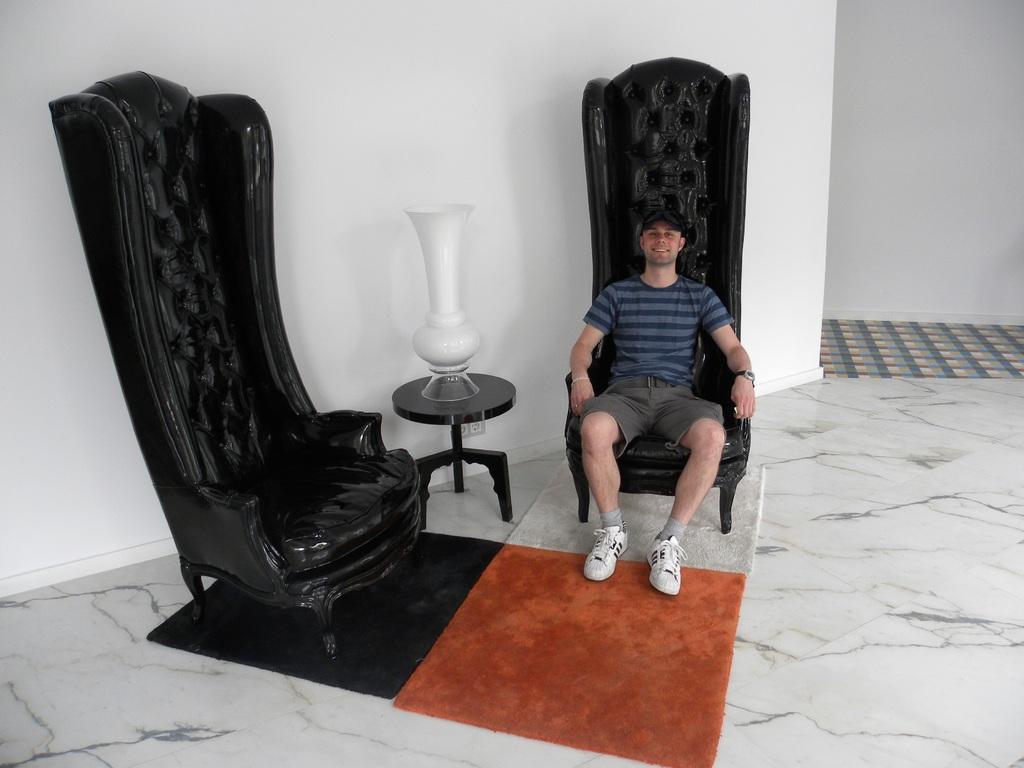How would you summarize this image in a sentence or two? This is the picture of a room. In this image there is a person sitting on the chair and there are two chairs and there is a flower vase on the table. At the bottom there are mats. At the back there is wall. At the bottom there is a floor. 